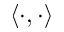Convert formula to latex. <formula><loc_0><loc_0><loc_500><loc_500>\langle \cdot , \cdot \rangle</formula> 